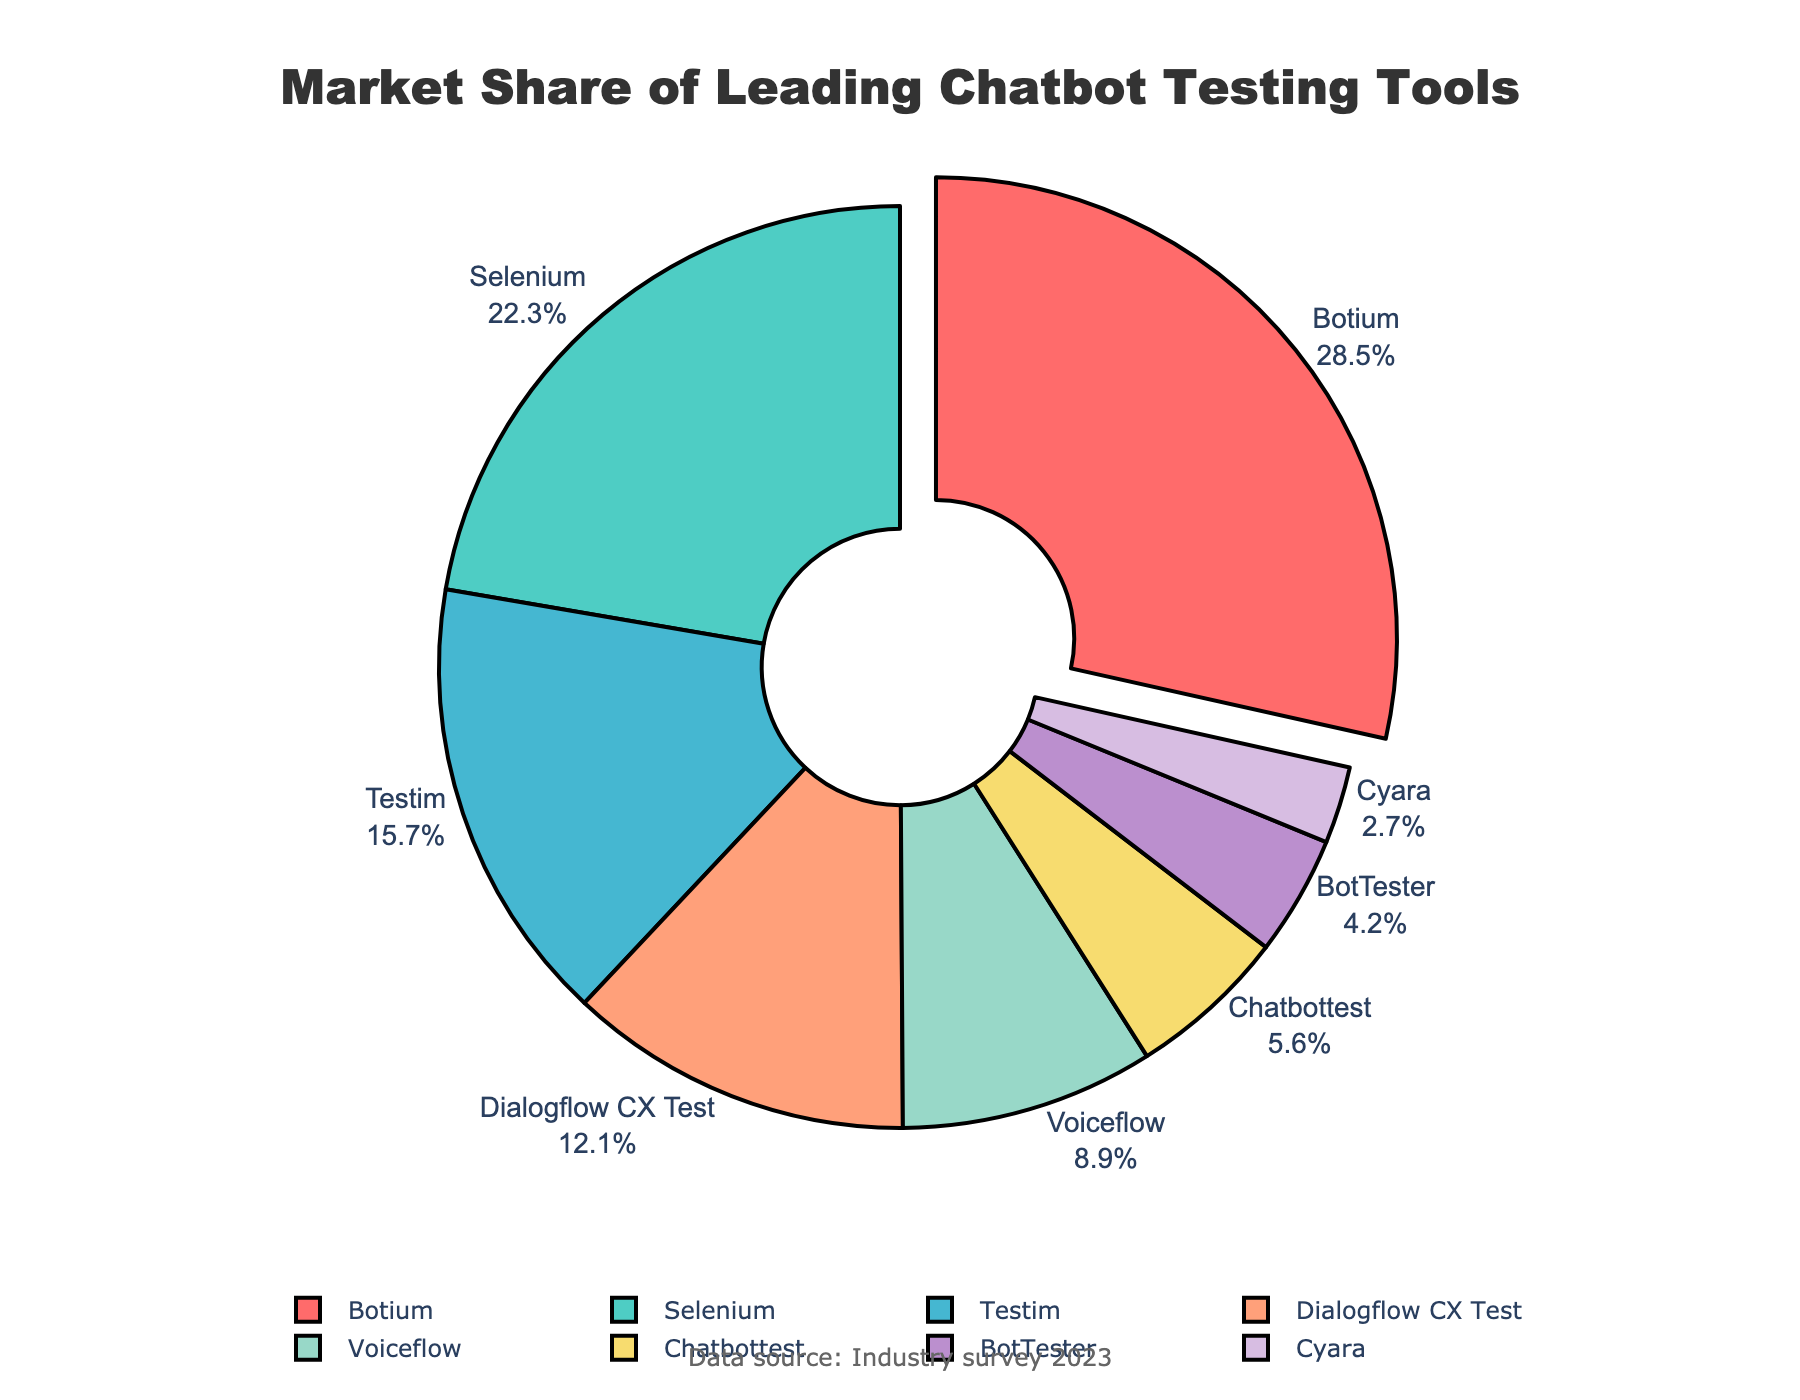What's the market share of Botium? The figure shows the percentage of market share for each tool. Locate the label for Botium, which is pulled out of the pie chart for emphasis; the percentage shown there is Botium's market share.
Answer: 28.5% What is the combined market share of Testim and Chatbottest? Add the market shares of Testim and Chatbottest: 15.7% (Testim) + 5.6% (Chatbottest) = 21.3%.
Answer: 21.3% Which tool has the smallest market share? Look for the label with the smallest percentage on the pie chart. The corresponding label identifies the tool with the smallest market share.
Answer: Cyara Between Selenium and Dialogflow CX Test, which tool has a higher market share and by how much? Compare the market shares of Selenium and Dialogflow CX Test. Selenium has a market share of 22.3%, and Dialogflow CX Test has 12.1%. Subtract Dialogflow CX Test's share from Selenium's: 22.3% - 12.1% = 10.2%.
Answer: Selenium by 10.2% What is the total market share of tools with less than 10% market share each? Sum the market shares of Voiceflow, Chatbottest, BotTester, and Cyara, as each has less than 10%: 8.9% + 5.6% + 4.2% + 2.7% = 21.4%.
Answer: 21.4% Which tool is represented by the red color in the pie chart? Identify the section of the pie chart that is colored red by examining the color legend or visual cues. The prominent red section corresponds to Botium.
Answer: Botium What is the average market share of the top three tools? Average the market shares of the top three tools: (Botium 28.5%, Selenium 22.3%, Testim 15.7%). Sum their shares: 28.5% + 22.3% + 15.7% = 66.5%. Then divide by 3: 66.5% / 3 ≈ 22.17%.
Answer: 22.17% How many tools have a market share greater than 20%? Count the labels with market shares greater than 20% as shown on the pie chart. Botium (28.5%) and Selenium (22.3%) are the only tools that meet this criterion.
Answer: 2 What's the difference in market share between the tool with the highest share and the tool with the lowest? Subtract the smallest market share from the largest. Botium (28.5%) - Cyara (2.7%) = 28.5% - 2.7% = 25.8%.
Answer: 25.8% 